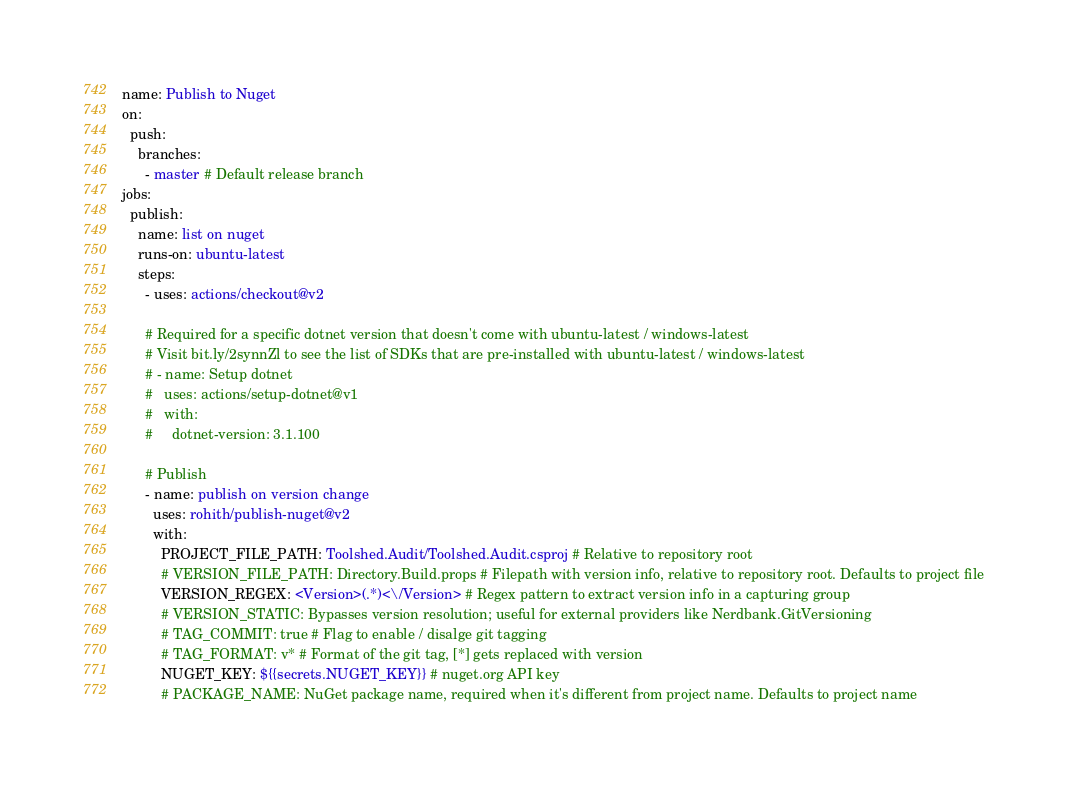<code> <loc_0><loc_0><loc_500><loc_500><_YAML_>name: Publish to Nuget
on:
  push:
    branches:
      - master # Default release branch
jobs:
  publish:
    name: list on nuget
    runs-on: ubuntu-latest
    steps:
      - uses: actions/checkout@v2

      # Required for a specific dotnet version that doesn't come with ubuntu-latest / windows-latest
      # Visit bit.ly/2synnZl to see the list of SDKs that are pre-installed with ubuntu-latest / windows-latest
      # - name: Setup dotnet
      #   uses: actions/setup-dotnet@v1
      #   with:
      #     dotnet-version: 3.1.100
      
      # Publish
      - name: publish on version change
        uses: rohith/publish-nuget@v2
        with:
          PROJECT_FILE_PATH: Toolshed.Audit/Toolshed.Audit.csproj # Relative to repository root
          # VERSION_FILE_PATH: Directory.Build.props # Filepath with version info, relative to repository root. Defaults to project file
          VERSION_REGEX: <Version>(.*)<\/Version> # Regex pattern to extract version info in a capturing group
          # VERSION_STATIC: Bypasses version resolution; useful for external providers like Nerdbank.GitVersioning
          # TAG_COMMIT: true # Flag to enable / disalge git tagging
          # TAG_FORMAT: v* # Format of the git tag, [*] gets replaced with version
          NUGET_KEY: ${{secrets.NUGET_KEY}} # nuget.org API key
          # PACKAGE_NAME: NuGet package name, required when it's different from project name. Defaults to project name
</code> 